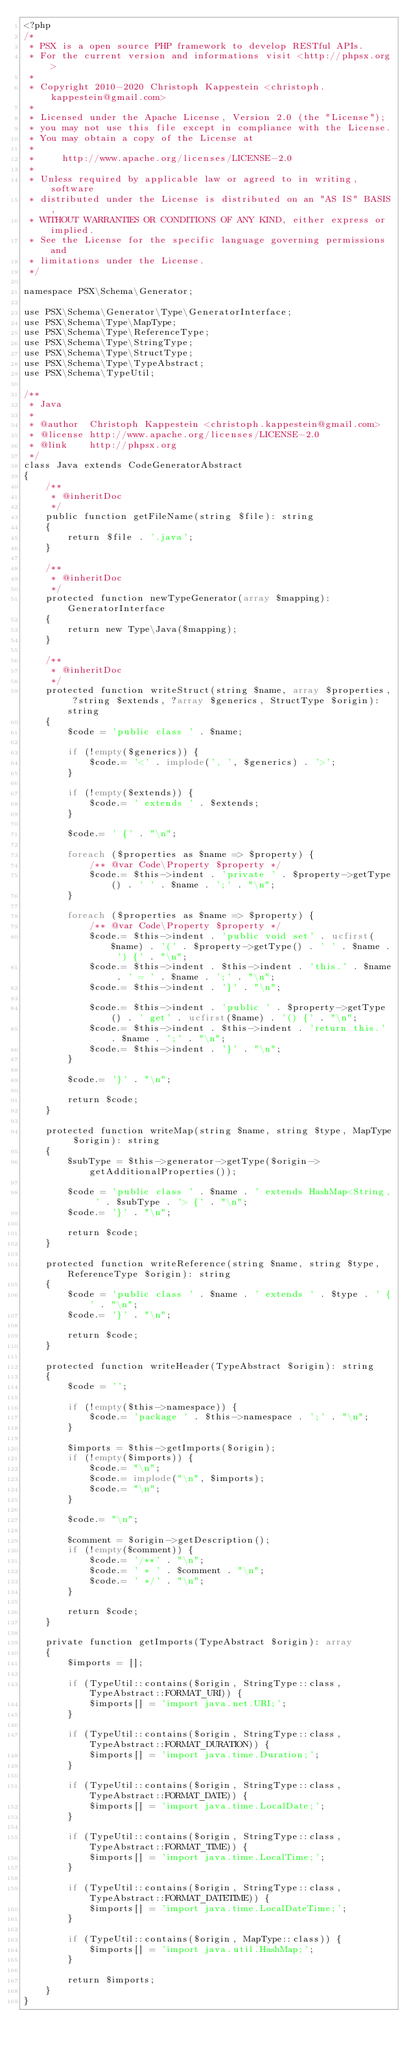Convert code to text. <code><loc_0><loc_0><loc_500><loc_500><_PHP_><?php
/*
 * PSX is a open source PHP framework to develop RESTful APIs.
 * For the current version and informations visit <http://phpsx.org>
 *
 * Copyright 2010-2020 Christoph Kappestein <christoph.kappestein@gmail.com>
 *
 * Licensed under the Apache License, Version 2.0 (the "License");
 * you may not use this file except in compliance with the License.
 * You may obtain a copy of the License at
 *
 *     http://www.apache.org/licenses/LICENSE-2.0
 *
 * Unless required by applicable law or agreed to in writing, software
 * distributed under the License is distributed on an "AS IS" BASIS,
 * WITHOUT WARRANTIES OR CONDITIONS OF ANY KIND, either express or implied.
 * See the License for the specific language governing permissions and
 * limitations under the License.
 */

namespace PSX\Schema\Generator;

use PSX\Schema\Generator\Type\GeneratorInterface;
use PSX\Schema\Type\MapType;
use PSX\Schema\Type\ReferenceType;
use PSX\Schema\Type\StringType;
use PSX\Schema\Type\StructType;
use PSX\Schema\Type\TypeAbstract;
use PSX\Schema\TypeUtil;

/**
 * Java
 *
 * @author  Christoph Kappestein <christoph.kappestein@gmail.com>
 * @license http://www.apache.org/licenses/LICENSE-2.0
 * @link    http://phpsx.org
 */
class Java extends CodeGeneratorAbstract
{
    /**
     * @inheritDoc
     */
    public function getFileName(string $file): string
    {
        return $file . '.java';
    }

    /**
     * @inheritDoc
     */
    protected function newTypeGenerator(array $mapping): GeneratorInterface
    {
        return new Type\Java($mapping);
    }

    /**
     * @inheritDoc
     */
    protected function writeStruct(string $name, array $properties, ?string $extends, ?array $generics, StructType $origin): string
    {
        $code = 'public class ' . $name;

        if (!empty($generics)) {
            $code.= '<' . implode(', ', $generics) . '>';
        }

        if (!empty($extends)) {
            $code.= ' extends ' . $extends;
        }

        $code.= ' {' . "\n";

        foreach ($properties as $name => $property) {
            /** @var Code\Property $property */
            $code.= $this->indent . 'private ' . $property->getType() . ' ' . $name . ';' . "\n";
        }

        foreach ($properties as $name => $property) {
            /** @var Code\Property $property */
            $code.= $this->indent . 'public void set' . ucfirst($name) . '(' . $property->getType() . ' ' . $name . ') {' . "\n";
            $code.= $this->indent . $this->indent . 'this.' . $name . ' = ' . $name . ';' . "\n";
            $code.= $this->indent . '}' . "\n";

            $code.= $this->indent . 'public ' . $property->getType() . ' get' . ucfirst($name) . '() {' . "\n";
            $code.= $this->indent . $this->indent . 'return this.' . $name . ';' . "\n";
            $code.= $this->indent . '}' . "\n";
        }

        $code.= '}' . "\n";

        return $code;
    }

    protected function writeMap(string $name, string $type, MapType $origin): string
    {
        $subType = $this->generator->getType($origin->getAdditionalProperties());

        $code = 'public class ' . $name . ' extends HashMap<String, ' . $subType . '> {' . "\n";
        $code.= '}' . "\n";

        return $code;
    }

    protected function writeReference(string $name, string $type, ReferenceType $origin): string
    {
        $code = 'public class ' . $name . ' extends ' . $type . ' {' . "\n";
        $code.= '}' . "\n";

        return $code;
    }

    protected function writeHeader(TypeAbstract $origin): string
    {
        $code = '';

        if (!empty($this->namespace)) {
            $code.= 'package ' . $this->namespace . ';' . "\n";
        }

        $imports = $this->getImports($origin);
        if (!empty($imports)) {
            $code.= "\n";
            $code.= implode("\n", $imports);
            $code.= "\n";
        }

        $code.= "\n";

        $comment = $origin->getDescription();
        if (!empty($comment)) {
            $code.= '/**' . "\n";
            $code.= ' * ' . $comment . "\n";
            $code.= ' */' . "\n";
        }

        return $code;
    }

    private function getImports(TypeAbstract $origin): array
    {
        $imports = [];

        if (TypeUtil::contains($origin, StringType::class, TypeAbstract::FORMAT_URI)) {
            $imports[] = 'import java.net.URI;';
        }

        if (TypeUtil::contains($origin, StringType::class, TypeAbstract::FORMAT_DURATION)) {
            $imports[] = 'import java.time.Duration;';
        }

        if (TypeUtil::contains($origin, StringType::class, TypeAbstract::FORMAT_DATE)) {
            $imports[] = 'import java.time.LocalDate;';
        }

        if (TypeUtil::contains($origin, StringType::class, TypeAbstract::FORMAT_TIME)) {
            $imports[] = 'import java.time.LocalTime;';
        }

        if (TypeUtil::contains($origin, StringType::class, TypeAbstract::FORMAT_DATETIME)) {
            $imports[] = 'import java.time.LocalDateTime;';
        }

        if (TypeUtil::contains($origin, MapType::class)) {
            $imports[] = 'import java.util.HashMap;';
        }

        return $imports;
    }
}
</code> 